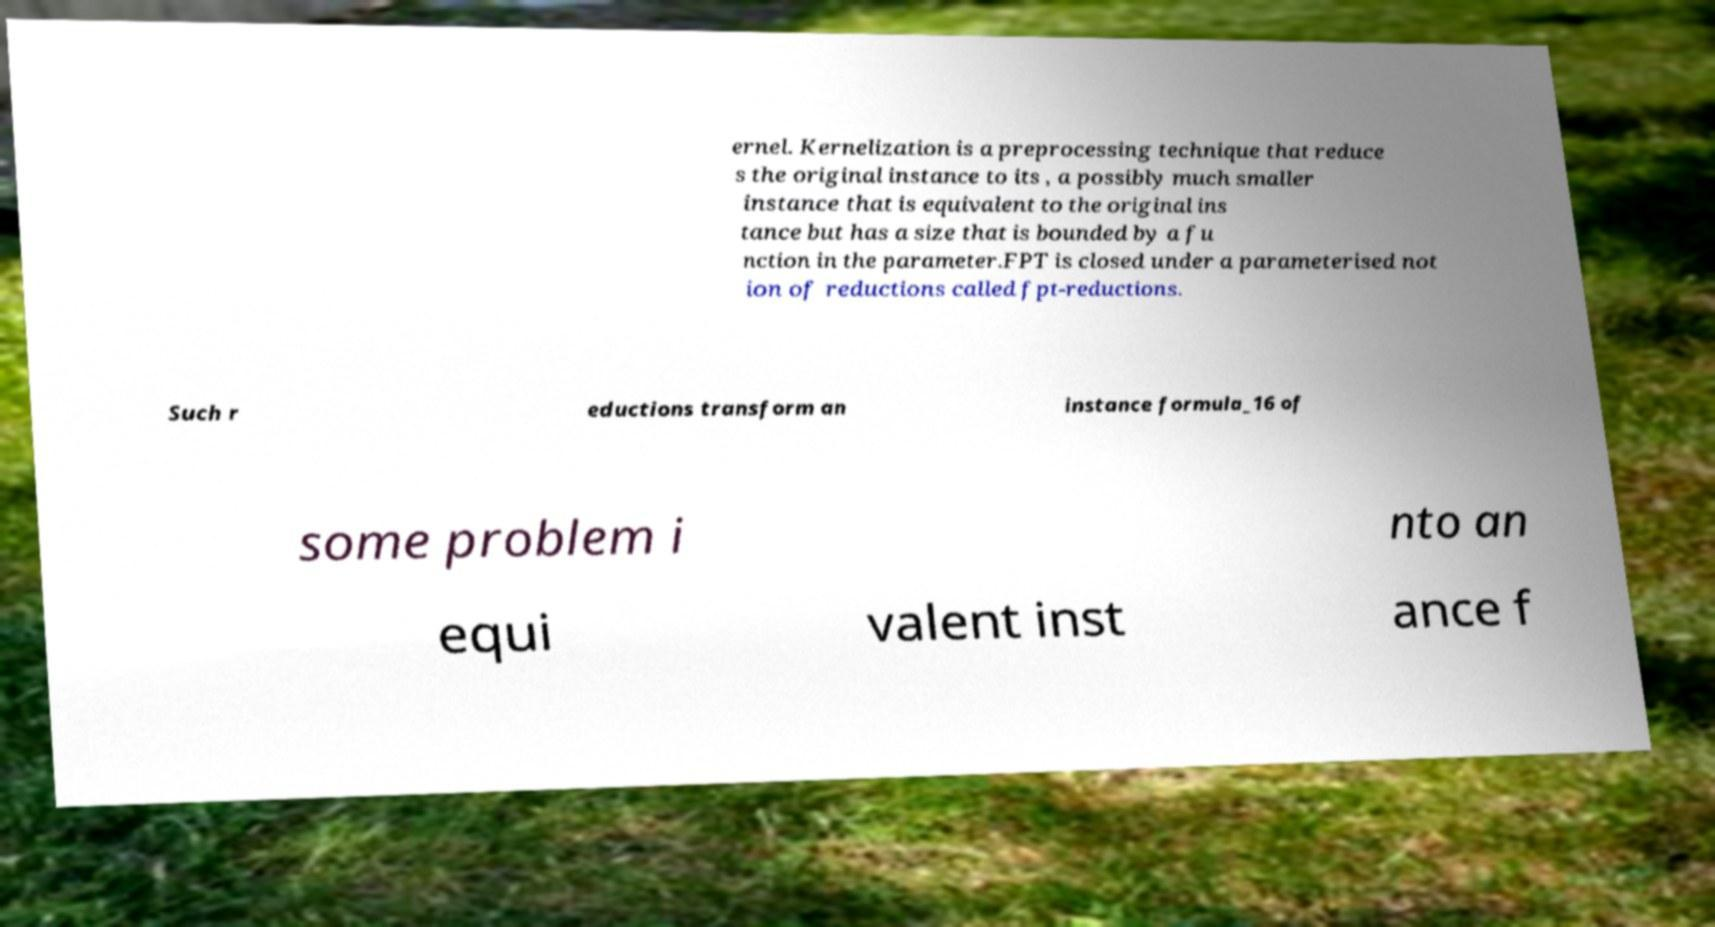What messages or text are displayed in this image? I need them in a readable, typed format. ernel. Kernelization is a preprocessing technique that reduce s the original instance to its , a possibly much smaller instance that is equivalent to the original ins tance but has a size that is bounded by a fu nction in the parameter.FPT is closed under a parameterised not ion of reductions called fpt-reductions. Such r eductions transform an instance formula_16 of some problem i nto an equi valent inst ance f 